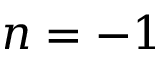Convert formula to latex. <formula><loc_0><loc_0><loc_500><loc_500>n = - 1</formula> 